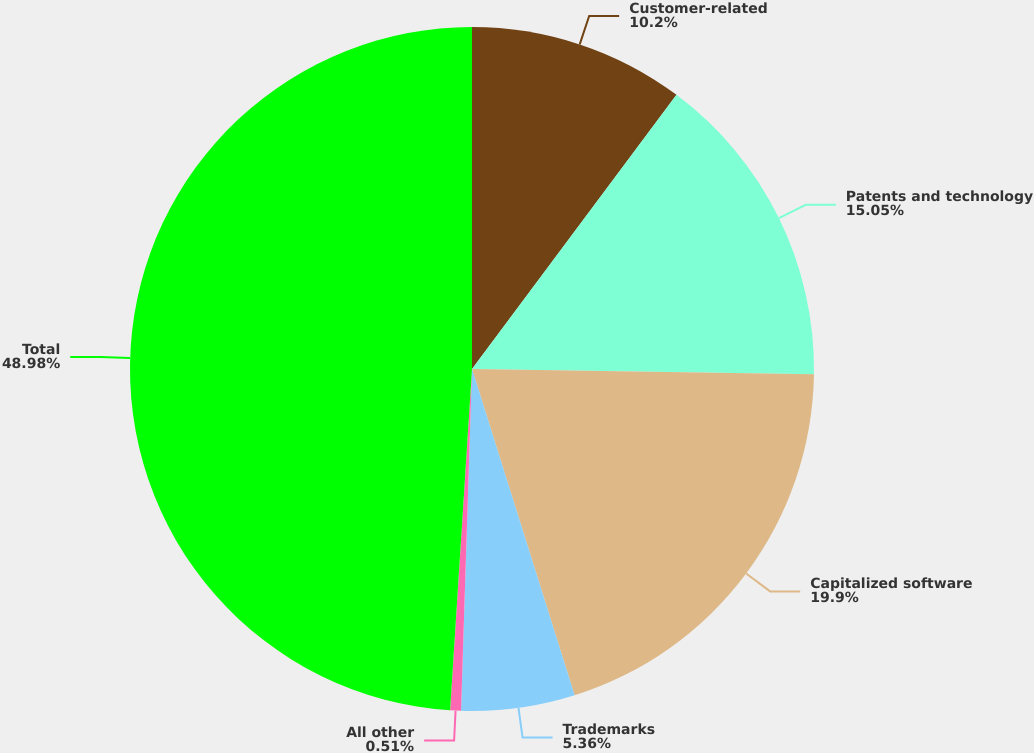<chart> <loc_0><loc_0><loc_500><loc_500><pie_chart><fcel>Customer-related<fcel>Patents and technology<fcel>Capitalized software<fcel>Trademarks<fcel>All other<fcel>Total<nl><fcel>10.2%<fcel>15.05%<fcel>19.9%<fcel>5.36%<fcel>0.51%<fcel>48.98%<nl></chart> 